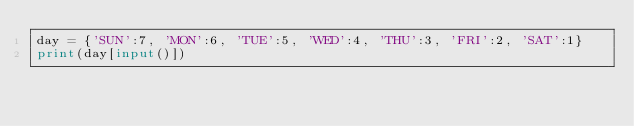<code> <loc_0><loc_0><loc_500><loc_500><_Python_>day = {'SUN':7, 'MON':6, 'TUE':5, 'WED':4, 'THU':3, 'FRI':2, 'SAT':1}
print(day[input()])</code> 